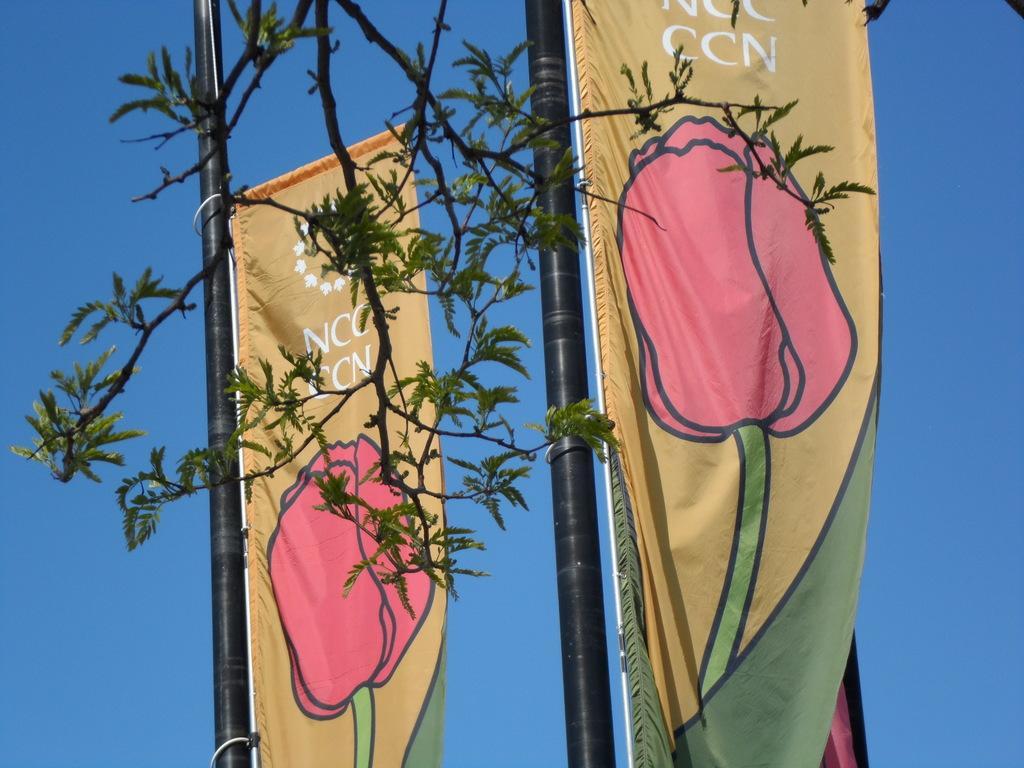Could you give a brief overview of what you see in this image? In this picture I can see the flags on the black poles. At the top I can see the tree branch. On the flag I can see the design of the flower. In the back I can see the sky. 